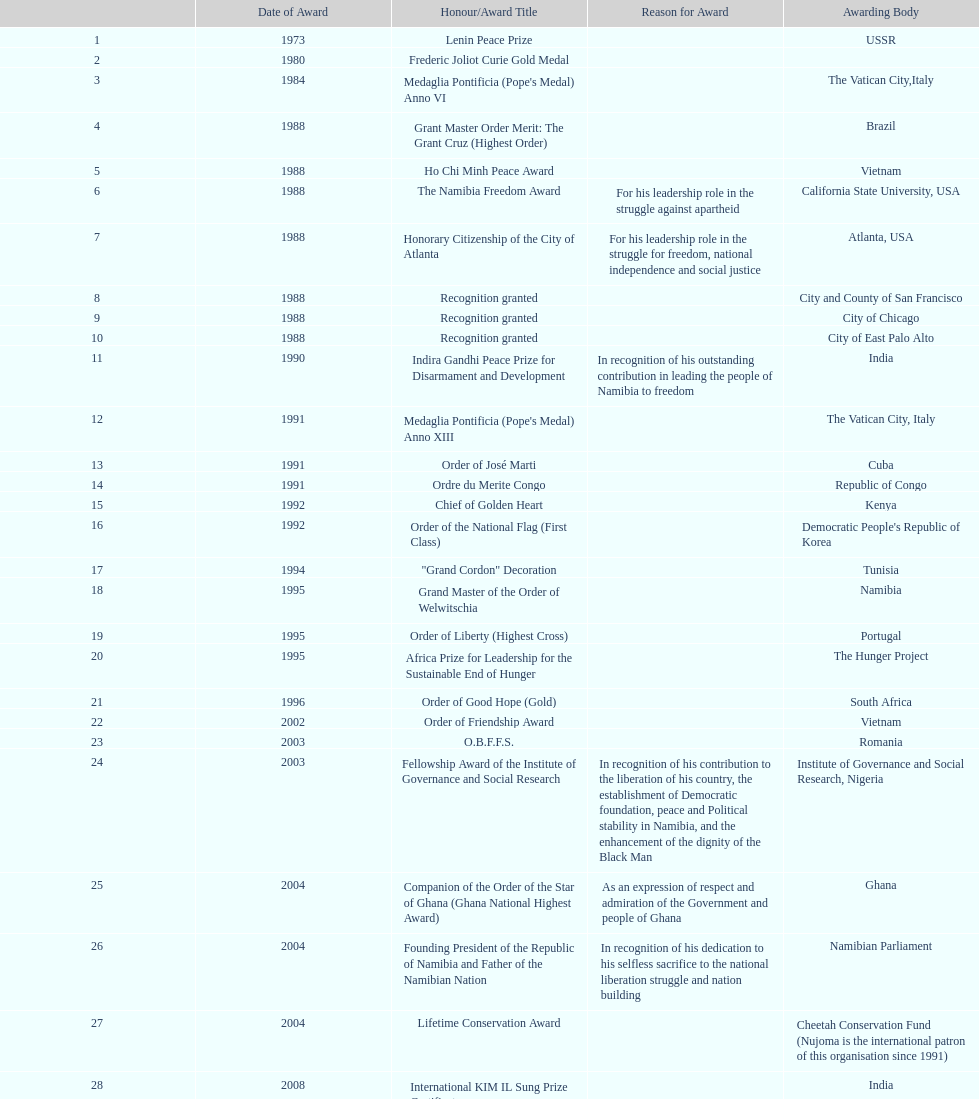After receiving the international kim il sung prize certificate, what was the name of the award/honor bestowed? Sir Seretse Khama SADC Meda. 